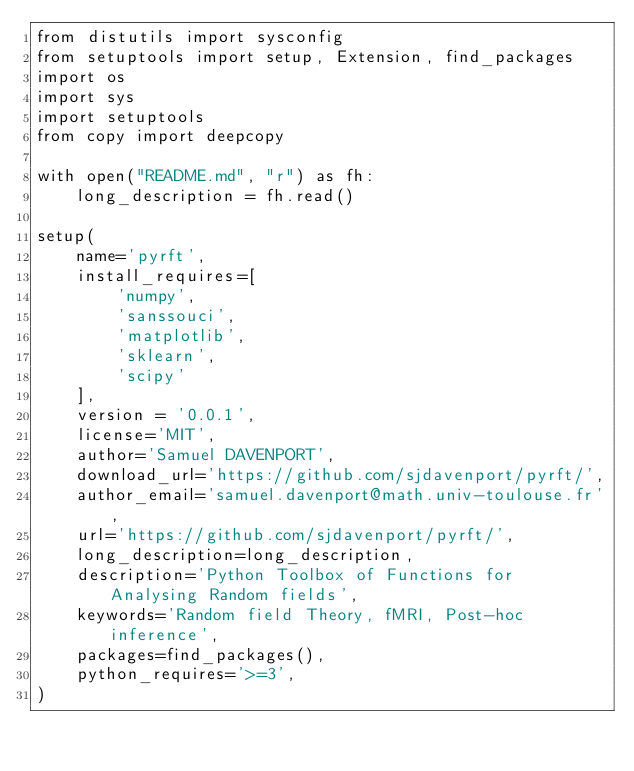<code> <loc_0><loc_0><loc_500><loc_500><_Python_>from distutils import sysconfig
from setuptools import setup, Extension, find_packages
import os
import sys
import setuptools
from copy import deepcopy

with open("README.md", "r") as fh:
    long_description = fh.read()

setup(
    name='pyrft',
    install_requires=[
        'numpy',
        'sanssouci',
        'matplotlib',
        'sklearn',
        'scipy'
    ],
    version = '0.0.1',
    license='MIT',
    author='Samuel DAVENPORT',
    download_url='https://github.com/sjdavenport/pyrft/',
    author_email='samuel.davenport@math.univ-toulouse.fr',
    url='https://github.com/sjdavenport/pyrft/',
    long_description=long_description,
    description='Python Toolbox of Functions for Analysing Random fields',
    keywords='Random field Theory, fMRI, Post-hoc inference',
    packages=find_packages(),
    python_requires='>=3',
)
</code> 